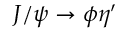Convert formula to latex. <formula><loc_0><loc_0><loc_500><loc_500>J / \psi \rightarrow \phi \eta ^ { \prime }</formula> 